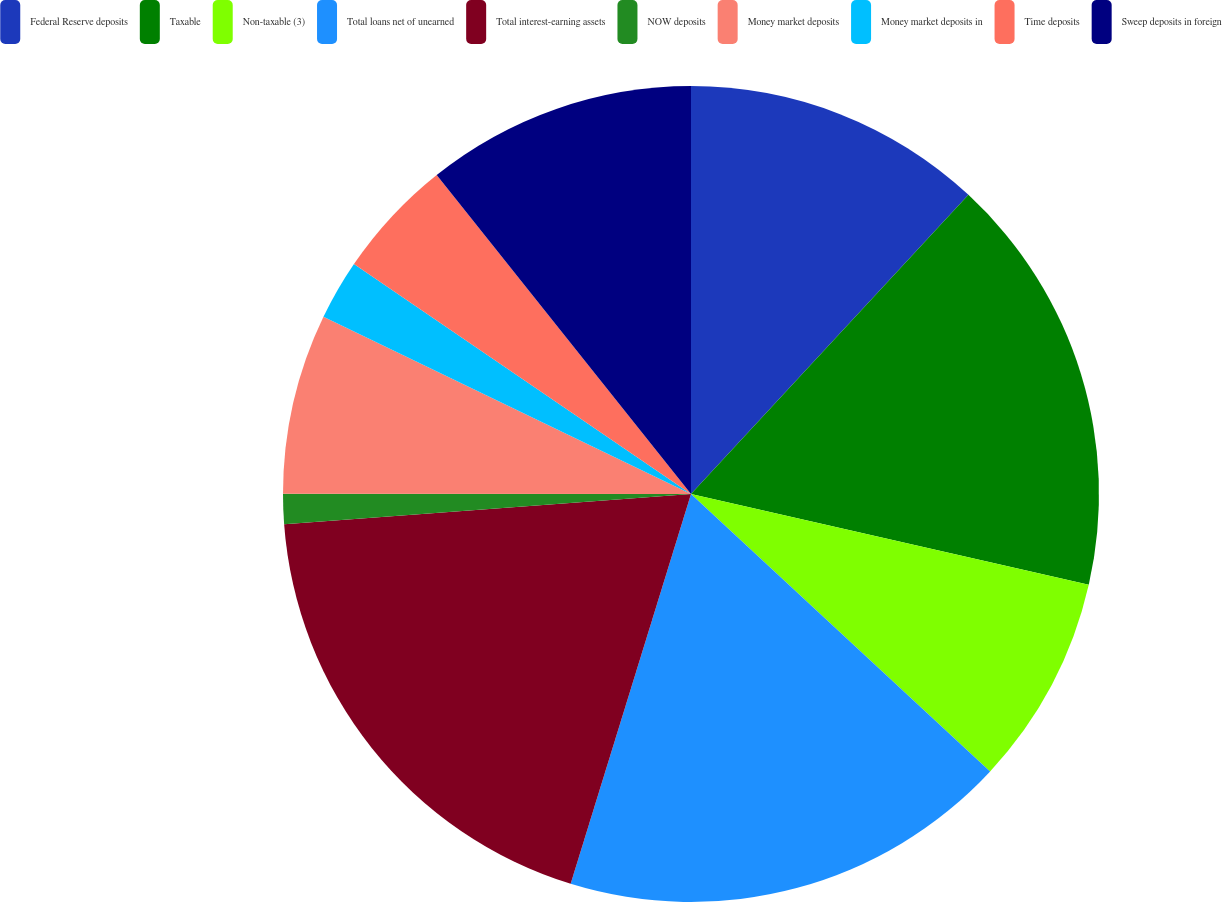Convert chart to OTSL. <chart><loc_0><loc_0><loc_500><loc_500><pie_chart><fcel>Federal Reserve deposits<fcel>Taxable<fcel>Non-taxable (3)<fcel>Total loans net of unearned<fcel>Total interest-earning assets<fcel>NOW deposits<fcel>Money market deposits<fcel>Money market deposits in<fcel>Time deposits<fcel>Sweep deposits in foreign<nl><fcel>11.9%<fcel>16.67%<fcel>8.33%<fcel>17.86%<fcel>19.05%<fcel>1.19%<fcel>7.14%<fcel>2.38%<fcel>4.76%<fcel>10.71%<nl></chart> 